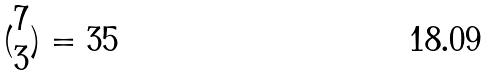Convert formula to latex. <formula><loc_0><loc_0><loc_500><loc_500>( \begin{matrix} 7 \\ 3 \end{matrix} ) = 3 5</formula> 